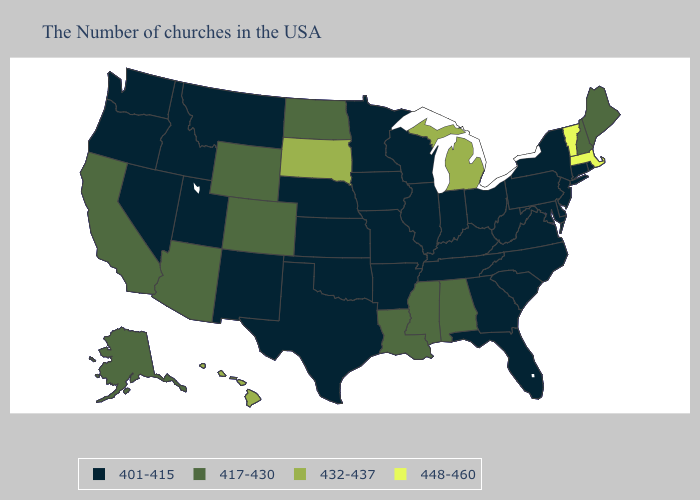What is the value of New Mexico?
Quick response, please. 401-415. Name the states that have a value in the range 448-460?
Be succinct. Massachusetts, Vermont. Among the states that border Alabama , does Mississippi have the lowest value?
Keep it brief. No. Does the first symbol in the legend represent the smallest category?
Quick response, please. Yes. Name the states that have a value in the range 417-430?
Short answer required. Maine, New Hampshire, Alabama, Mississippi, Louisiana, North Dakota, Wyoming, Colorado, Arizona, California, Alaska. Name the states that have a value in the range 417-430?
Give a very brief answer. Maine, New Hampshire, Alabama, Mississippi, Louisiana, North Dakota, Wyoming, Colorado, Arizona, California, Alaska. What is the value of Oregon?
Short answer required. 401-415. Does the map have missing data?
Quick response, please. No. Name the states that have a value in the range 417-430?
Keep it brief. Maine, New Hampshire, Alabama, Mississippi, Louisiana, North Dakota, Wyoming, Colorado, Arizona, California, Alaska. What is the value of Illinois?
Concise answer only. 401-415. Does Vermont have the highest value in the USA?
Give a very brief answer. Yes. Which states have the lowest value in the USA?
Give a very brief answer. Rhode Island, Connecticut, New York, New Jersey, Delaware, Maryland, Pennsylvania, Virginia, North Carolina, South Carolina, West Virginia, Ohio, Florida, Georgia, Kentucky, Indiana, Tennessee, Wisconsin, Illinois, Missouri, Arkansas, Minnesota, Iowa, Kansas, Nebraska, Oklahoma, Texas, New Mexico, Utah, Montana, Idaho, Nevada, Washington, Oregon. What is the value of Idaho?
Give a very brief answer. 401-415. What is the highest value in states that border Nebraska?
Be succinct. 432-437. Which states have the lowest value in the USA?
Quick response, please. Rhode Island, Connecticut, New York, New Jersey, Delaware, Maryland, Pennsylvania, Virginia, North Carolina, South Carolina, West Virginia, Ohio, Florida, Georgia, Kentucky, Indiana, Tennessee, Wisconsin, Illinois, Missouri, Arkansas, Minnesota, Iowa, Kansas, Nebraska, Oklahoma, Texas, New Mexico, Utah, Montana, Idaho, Nevada, Washington, Oregon. 